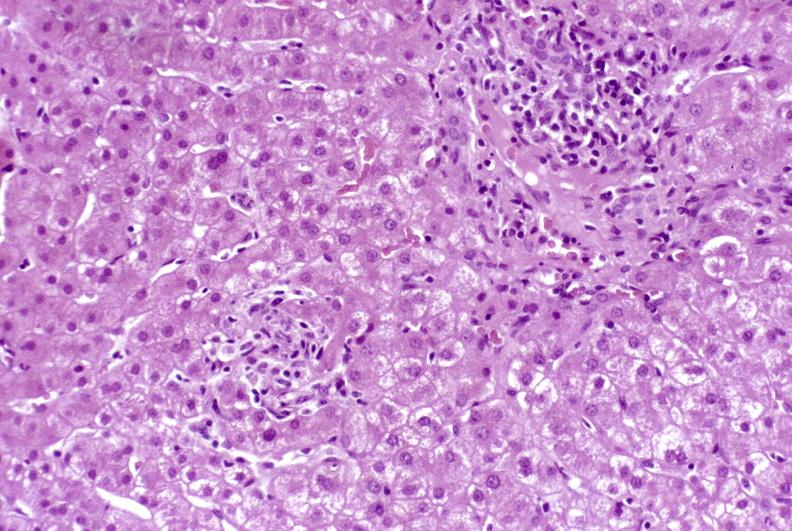does this image show granulomas?
Answer the question using a single word or phrase. Yes 